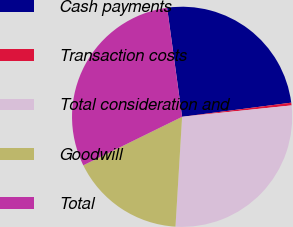Convert chart. <chart><loc_0><loc_0><loc_500><loc_500><pie_chart><fcel>Cash payments<fcel>Transaction costs<fcel>Total consideration and<fcel>Goodwill<fcel>Total<nl><fcel>25.13%<fcel>0.4%<fcel>27.61%<fcel>16.78%<fcel>30.09%<nl></chart> 